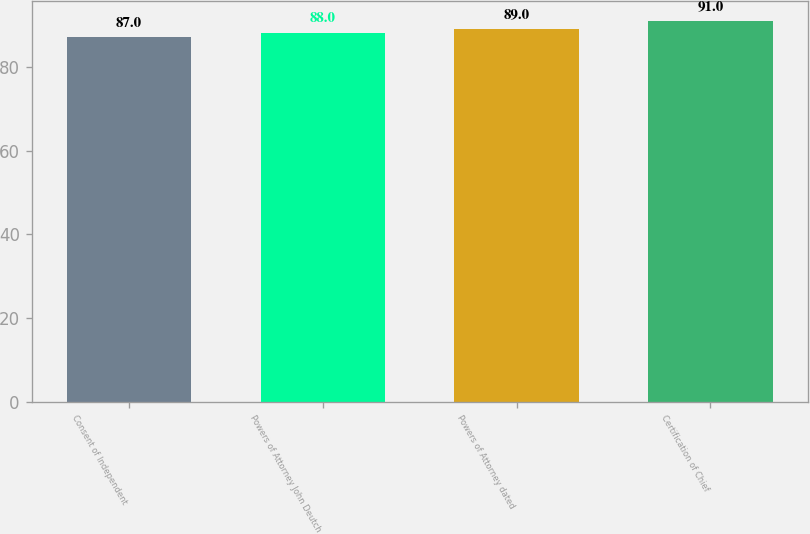Convert chart to OTSL. <chart><loc_0><loc_0><loc_500><loc_500><bar_chart><fcel>Consent of Independent<fcel>Powers of Attorney John Deutch<fcel>Powers of Attorney dated<fcel>Certification of Chief<nl><fcel>87<fcel>88<fcel>89<fcel>91<nl></chart> 